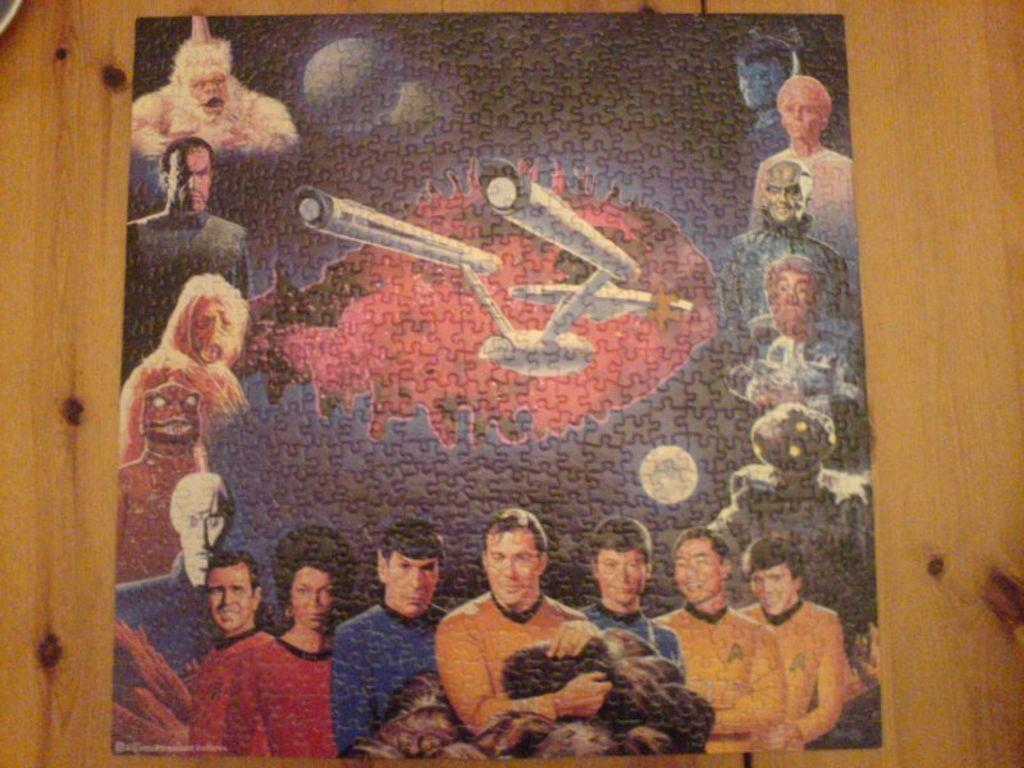What is the main object in the image? There is a puzzle card in the image. Where is the puzzle card located? The puzzle card is on a platform. What types of images are present on the puzzle card? The puzzle card contains pictures of persons, a plane, the moon, and aliens. What type of peace can be seen on the puzzle card? There is no reference to peace in the image; it features a puzzle card with various pictures, including persons, a plane, the moon, and aliens. 